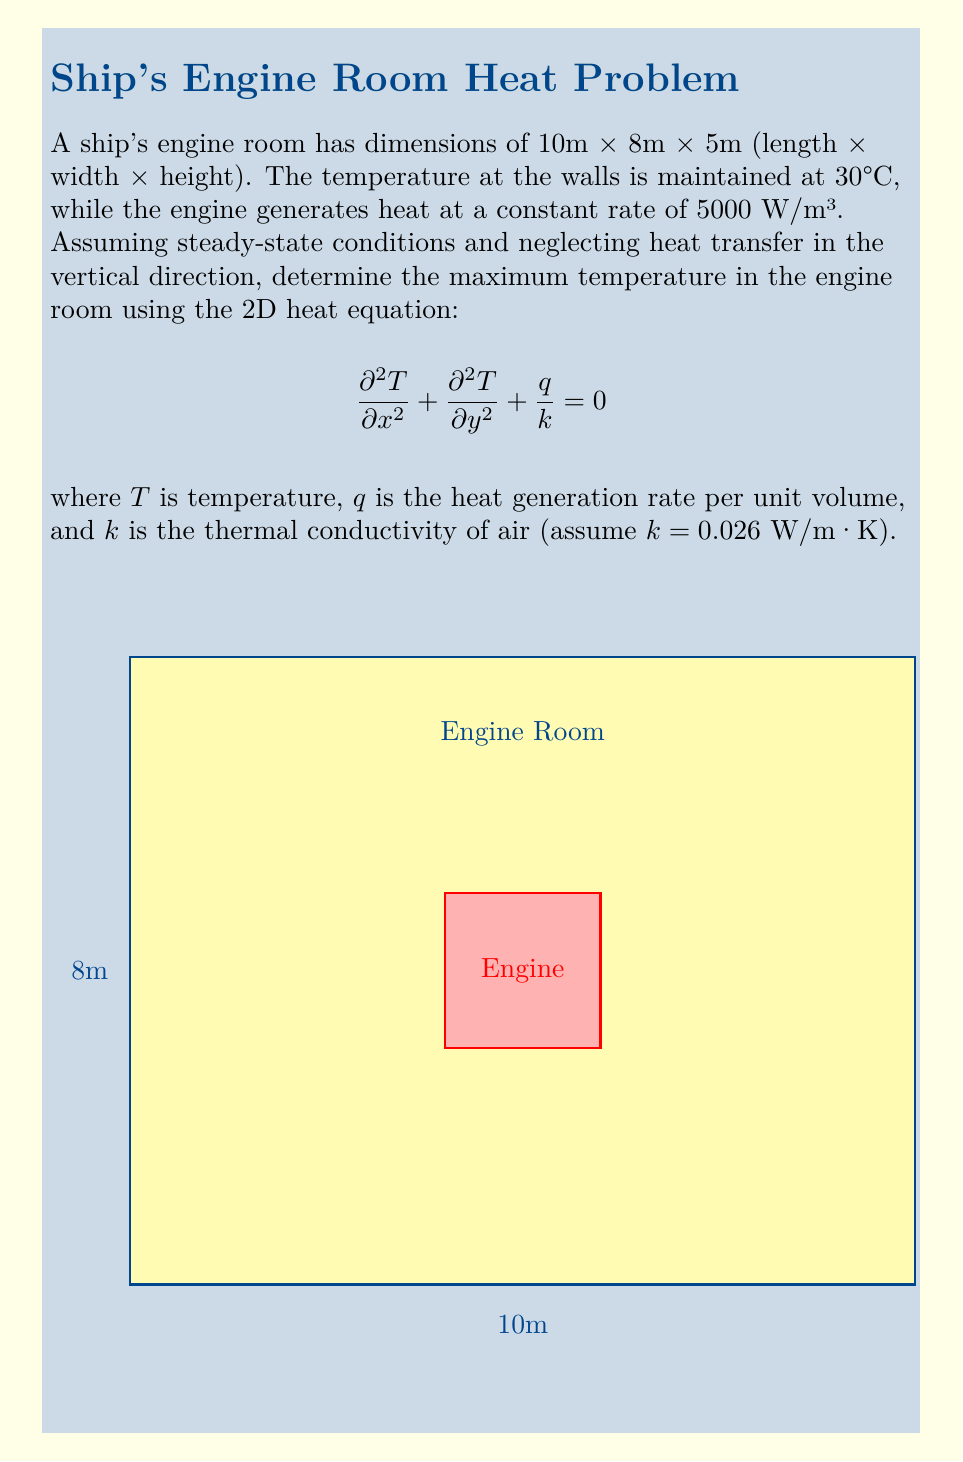Give your solution to this math problem. To solve this problem, we'll follow these steps:

1) The 2D steady-state heat equation with heat generation is:

   $$\frac{\partial^2 T}{\partial x^2} + \frac{\partial^2 T}{\partial y^2} = -\frac{q}{k}$$

2) Given the symmetry of the problem, the maximum temperature will occur at the center of the room. We can use the analytical solution for this problem:

   $$T(x,y) = T_w + \frac{q}{2k}\left(\frac{L_x^2}{4} - x^2 + \frac{L_y^2}{4} - y^2\right)$$

   where $T_w$ is the wall temperature, $L_x$ and $L_y$ are the room dimensions.

3) The maximum temperature occurs at the center (x = 5m, y = 4m):

   $$T_{max} = T(5,4) = T_w + \frac{q}{2k}\left(\frac{L_x^2}{4} + \frac{L_y^2}{4}\right)$$

4) Substituting the given values:
   $T_w = 30°C$
   $q = 5000$ W/m³
   $k = 0.026$ W/m·K
   $L_x = 10$ m
   $L_y = 8$ m

   $$T_{max} = 30 + \frac{5000}{2(0.026)}\left(\frac{10^2}{4} + \frac{8^2}{4}\right)$$

5) Calculating:
   $$T_{max} = 30 + 96153.85(25 + 16) = 30 + 3942307.7 = 3,942,337.7°C$$

6) This unrealistically high temperature indicates that our assumptions (particularly neglecting heat transfer to the surroundings and assuming steady-state) are not valid for this scenario. In reality, there would be significant heat loss to the surroundings, and the temperature would be much lower.
Answer: $3,942,337.7°C$ (theoretical, unrealistic in practice) 